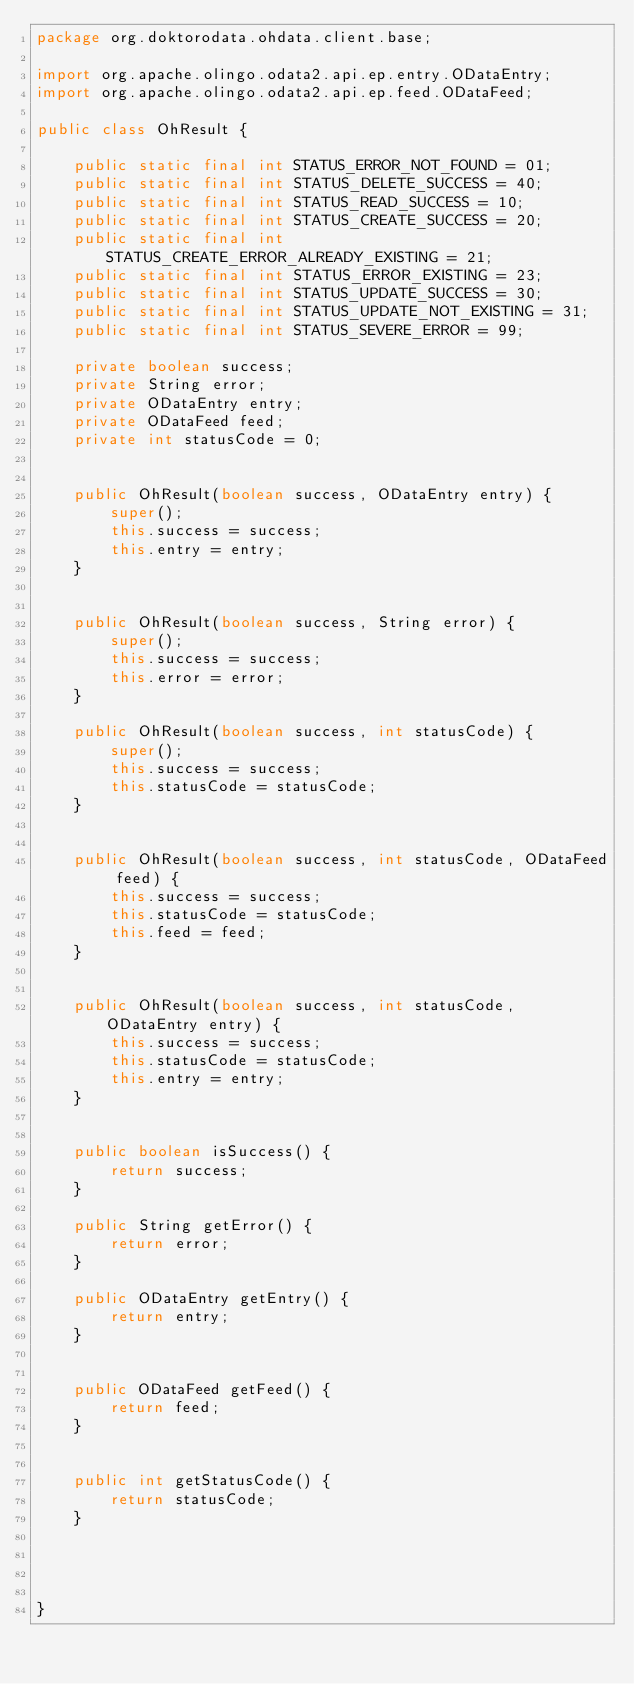<code> <loc_0><loc_0><loc_500><loc_500><_Java_>package org.doktorodata.ohdata.client.base;

import org.apache.olingo.odata2.api.ep.entry.ODataEntry;
import org.apache.olingo.odata2.api.ep.feed.ODataFeed;

public class OhResult {

	public static final int STATUS_ERROR_NOT_FOUND = 01;
	public static final int STATUS_DELETE_SUCCESS = 40;
	public static final int STATUS_READ_SUCCESS = 10;
	public static final int STATUS_CREATE_SUCCESS = 20;
	public static final int STATUS_CREATE_ERROR_ALREADY_EXISTING = 21;
	public static final int STATUS_ERROR_EXISTING = 23;
	public static final int STATUS_UPDATE_SUCCESS = 30;
	public static final int STATUS_UPDATE_NOT_EXISTING = 31;
	public static final int STATUS_SEVERE_ERROR = 99;
	
	private boolean success;
	private String error;
	private ODataEntry entry;
	private ODataFeed feed;
	private int statusCode = 0;
	

	public OhResult(boolean success, ODataEntry entry) {
		super();
		this.success = success;
		this.entry = entry;
	}
	

	public OhResult(boolean success, String error) {
		super();
		this.success = success;
		this.error = error;
	}

	public OhResult(boolean success, int statusCode) {
		super();
		this.success = success;
		this.statusCode = statusCode;
	}


	public OhResult(boolean success, int statusCode, ODataFeed feed) {
		this.success = success;
		this.statusCode = statusCode;
		this.feed = feed;
	}


	public OhResult(boolean success, int statusCode, ODataEntry entry) {
		this.success = success;
		this.statusCode = statusCode;
		this.entry = entry;
	}


	public boolean isSuccess() {
		return success;
	}
	
	public String getError() {
		return error;
	}
	
	public ODataEntry getEntry() {
		return entry;
	}


	public ODataFeed getFeed() {
		return feed;
	}


	public int getStatusCode() {
		return statusCode;
	}


	
	
}
</code> 